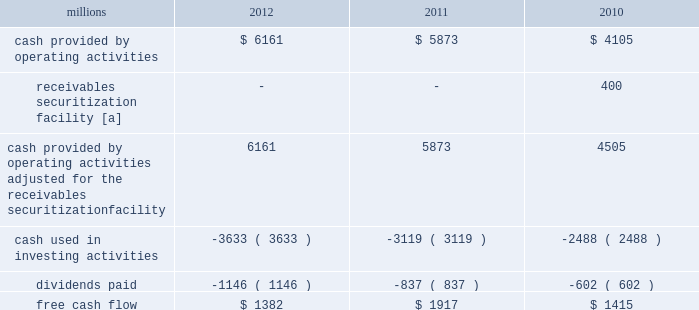F0b7 free cash flow 2013 cash generated by operating activities totaled $ 6.2 billion , reduced by $ 3.6 billion for cash used in investing activities and a 37% ( 37 % ) increase in dividends paid , yielding free cash flow of $ 1.4 billion .
Free cash flow is defined as cash provided by operating activities ( adjusted for the reclassification of our receivables securitization facility ) , less cash used in investing activities and dividends paid .
Free cash flow is not considered a financial measure under accounting principles generally accepted in the u.s .
( gaap ) by sec regulation g and item 10 of sec regulation s-k and may not be defined and calculated by other companies in the same manner .
We believe free cash flow is important to management and investors in evaluating our financial performance and measures our ability to generate cash without additional external financings .
Free cash flow should be considered in addition to , rather than as a substitute for , cash provided by operating activities .
The table reconciles cash provided by operating activities ( gaap measure ) to free cash flow ( non-gaap measure ) : millions 2012 2011 2010 .
[a] effective january 1 , 2010 , a new accounting standard required us to account for receivables transferred under our receivables securitization facility as secured borrowings in our consolidated statements of financial position and as financing activities in our consolidated statements of cash flows .
The receivables securitization facility is included in our free cash flow calculation to adjust cash provided by operating activities as though our receivables securitization facility had been accounted for under the new accounting standard for all periods presented .
2013 outlook f0b7 safety 2013 operating a safe railroad benefits our employees , our customers , our shareholders , and the communities we serve .
We will continue using a multi-faceted approach to safety , utilizing technology , risk assessment , quality control , training and employee engagement , and targeted capital investments .
We will continue using and expanding the deployment of total safety culture throughout our operations , which allows us to identify and implement best practices for employee and operational safety .
Derailment prevention and the reduction of grade crossing incidents are critical aspects of our safety programs .
We will continue our efforts to increase rail defect detection ; improve or close crossings ; and educate the public and law enforcement agencies about crossing safety through a combination of our own programs ( including risk assessment strategies ) , various industry programs and local community activities across our network .
F0b7 network operations 2013 we will continue focusing on our six critical initiatives to improve safety , service and productivity during 2013 .
We are seeing solid contributions from reducing variability , continuous improvements , and standard work .
Resource agility allows us to respond quickly to changing market conditions and network disruptions from weather or other events .
The railroad continues to benefit from capital investments that allow us to build capacity for growth and harden our infrastructure to reduce failure .
F0b7 fuel prices 2013 uncertainty about the economy makes projections of fuel prices difficult .
We again could see volatile fuel prices during the year , as they are sensitive to global and u.s .
Domestic demand , refining capacity , geopolitical events , weather conditions and other factors .
To reduce the impact of fuel price on earnings , we will continue seeking cost recovery from our customers through our fuel surcharge programs and expanding our fuel conservation efforts .
F0b7 capital plan 2013 in 2013 , we plan to make total capital investments of approximately $ 3.6 billion , including expenditures for positive train control ( ptc ) , which may be revised if business conditions warrant or if new laws or regulations affect our ability to generate sufficient returns on these investments .
( see further discussion in this item 7 under liquidity and capital resources 2013 capital plan. ) .
What percentage of 2012 operating cash flow was used for dividends? 
Computations: (1146 / 6161)
Answer: 0.18601. 